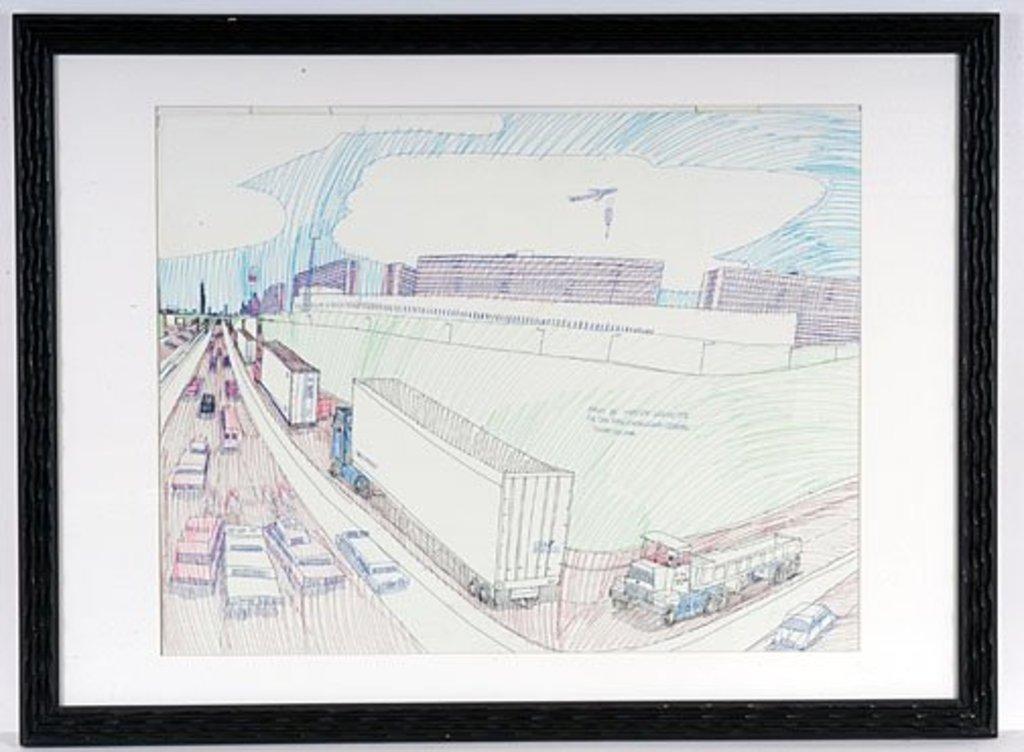How would you summarize this image in a sentence or two? In this image I see a frame and I see a white paper and on it I see the art and I see road on which there are vehicles and I see the buildings and the sky. 